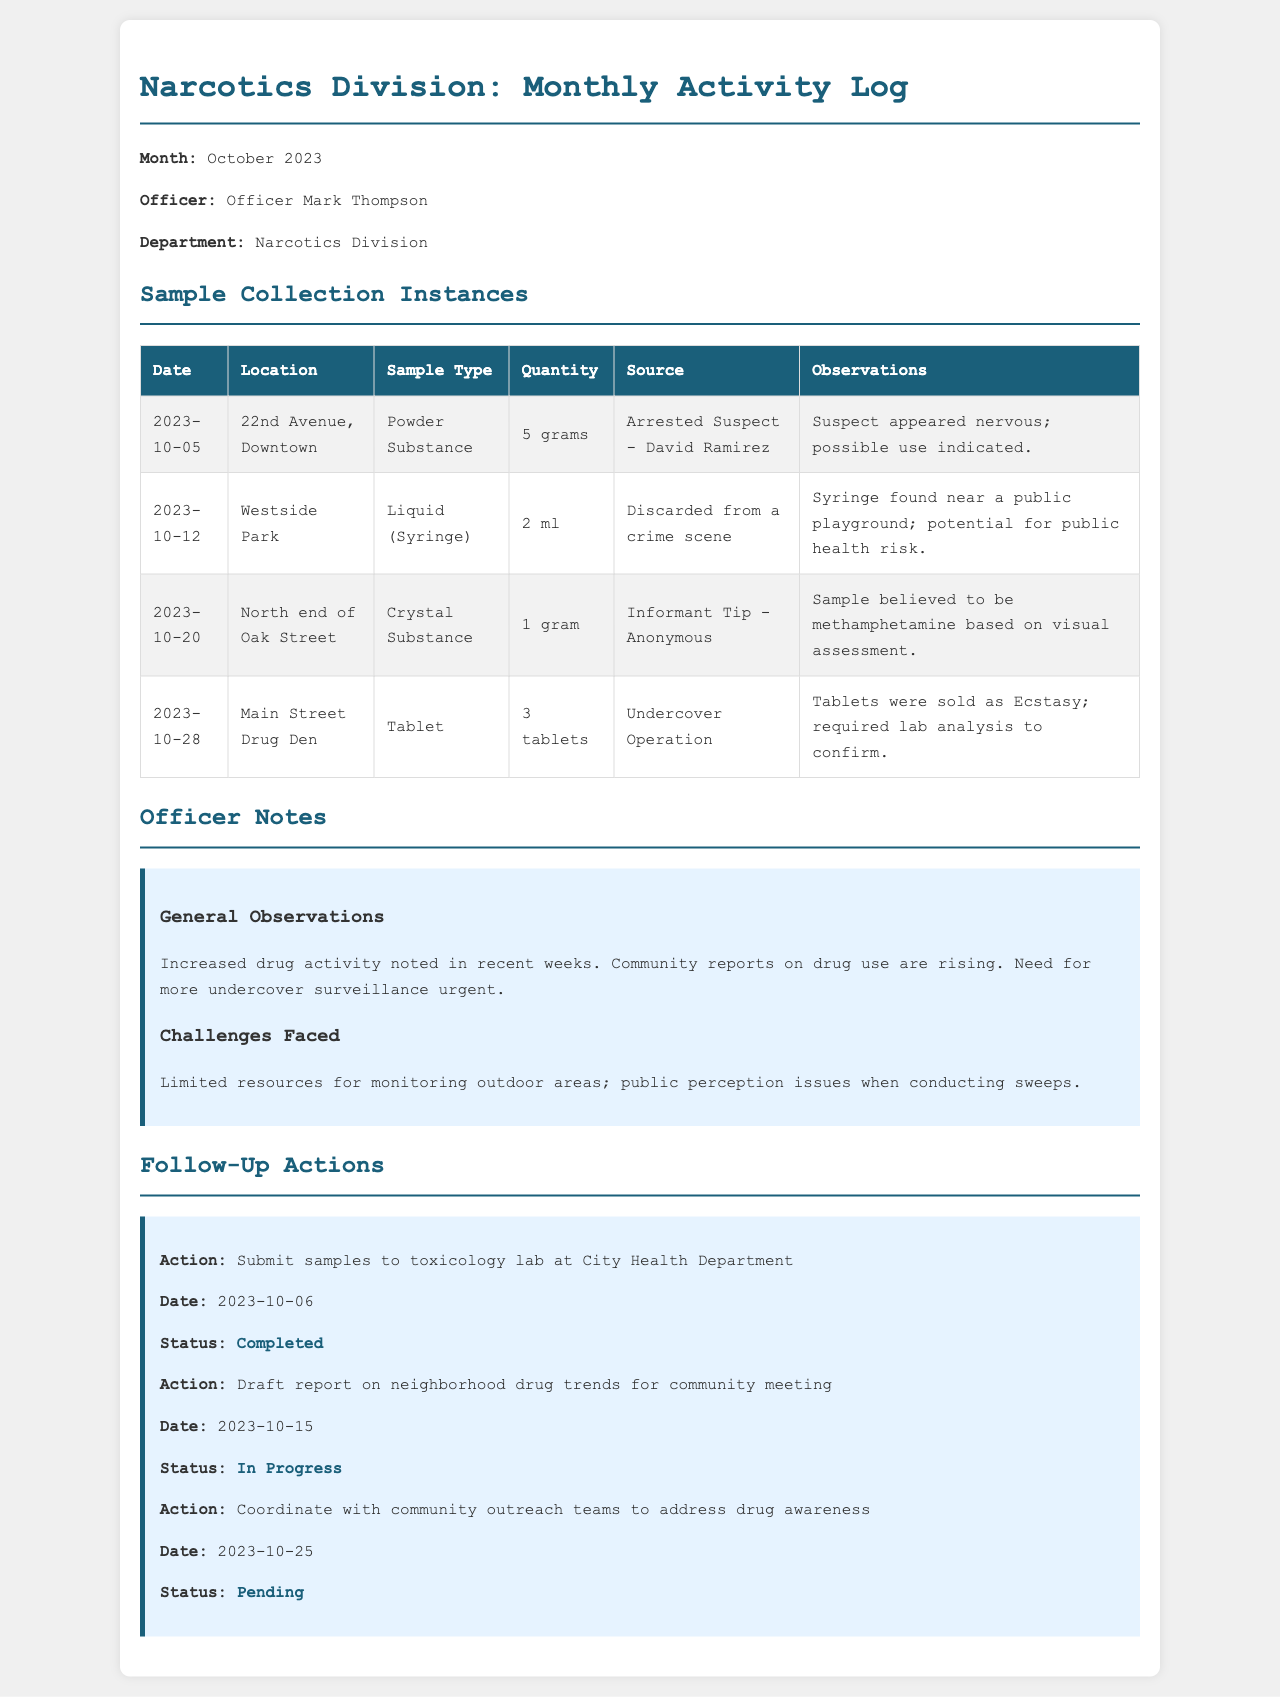What is the month of the activity log? The document states that the month of the activity log is clearly indicated at the beginning.
Answer: October 2023 Who is the officer in charge? The document specifies the name of the officer responsible for the activity log.
Answer: Officer Mark Thompson What type of sample was collected on October 12? This information can be found in the 'Sample Collection Instances' table, indicating the sample type collected on this date.
Answer: Liquid (Syringe) How many tablets were collected on October 28? The quantity of tablets collected is listed in the 'Sample Collection Instances' for that date.
Answer: 3 tablets What was the source of the powder substance collected on October 5? The source for this particular sample is clearly stated in the 'Sample Collection Instances' table.
Answer: Arrested Suspect - David Ramirez What is the status of the action to coordinate with community outreach teams? The status of this follow-up action is provided in the 'Follow-Up Actions' section of the document.
Answer: Pending What observation was made concerning community reports? The general observations section discusses the rising community reports, indicating the nature of the issue.
Answer: Rising What challenge was faced regarding outdoor areas? The document lists specific challenges faced in the section dedicated to officer notes.
Answer: Limited resources On what date was the sample submission to the toxicology lab completed? The date of completion for submitting samples is explicitly stated in the follow-up actions.
Answer: 2023-10-06 